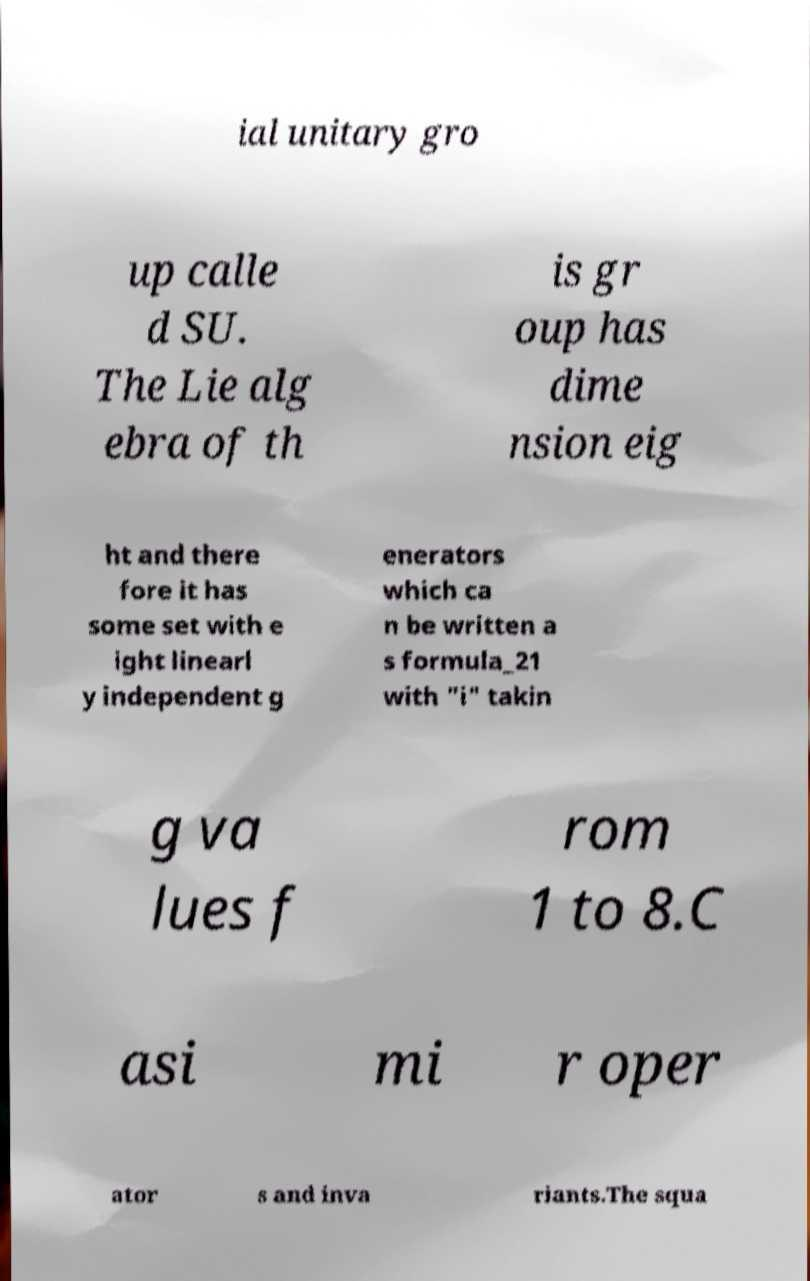What messages or text are displayed in this image? I need them in a readable, typed format. ial unitary gro up calle d SU. The Lie alg ebra of th is gr oup has dime nsion eig ht and there fore it has some set with e ight linearl y independent g enerators which ca n be written a s formula_21 with "i" takin g va lues f rom 1 to 8.C asi mi r oper ator s and inva riants.The squa 